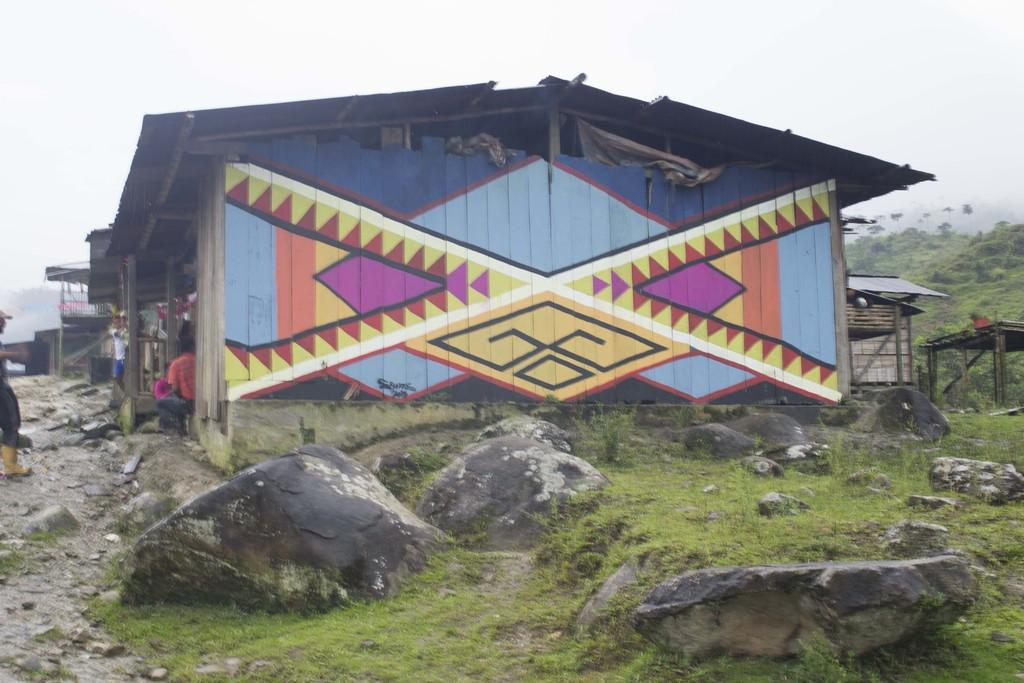What is the main structure in the center of the image? There is: There is a building with a roof in the center of the image. What can be seen at the bottom of the image? Rocks and grass are visible at the bottom of the image. What is visible in the background of the image? There is a sky visible in the background of the image. How many nerves are visible in the image? There are no nerves present in the image. The image features a building, rocks, grass, and a sky, but no biological elements like nerves are depicted. 